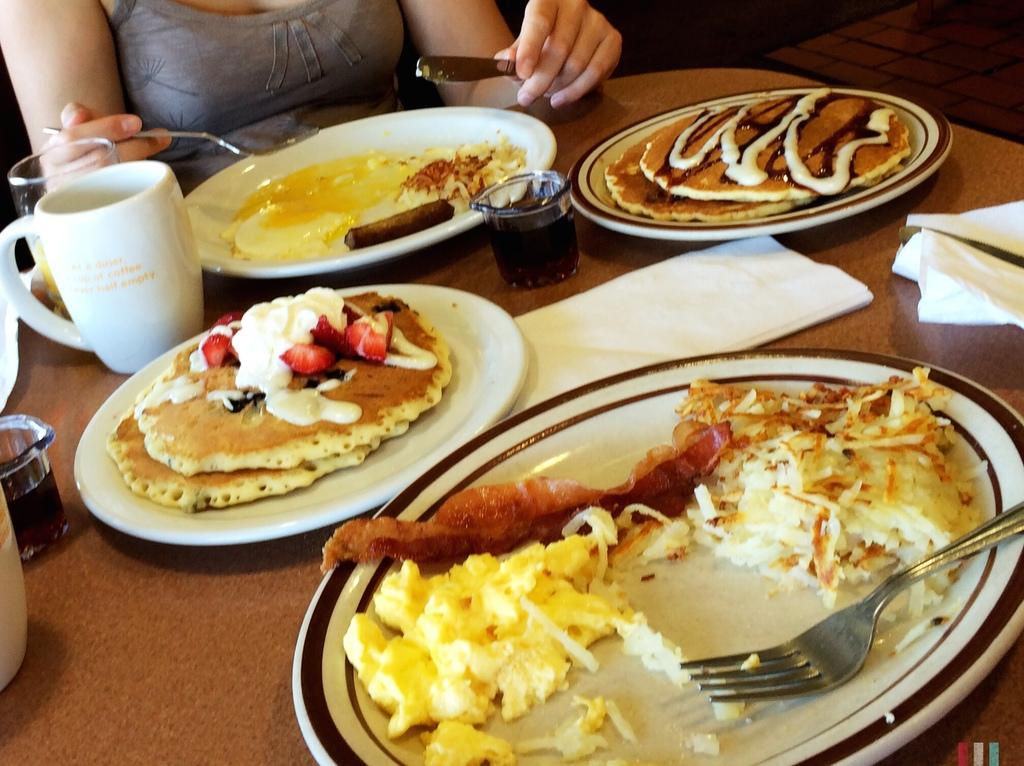What type of objects can be seen on the table in the image? There are plates, food, forks, cups, and glasses on the table in the image. What is the person in the image doing? The person is sitting and holding a fork and spoon. What might the person be using the fork and spoon for? The person might be using the fork and spoon to eat the food on the table. What type of trousers is the person wearing in the image? The provided facts do not mention the person's trousers, so we cannot determine the type of trousers they are wearing. 